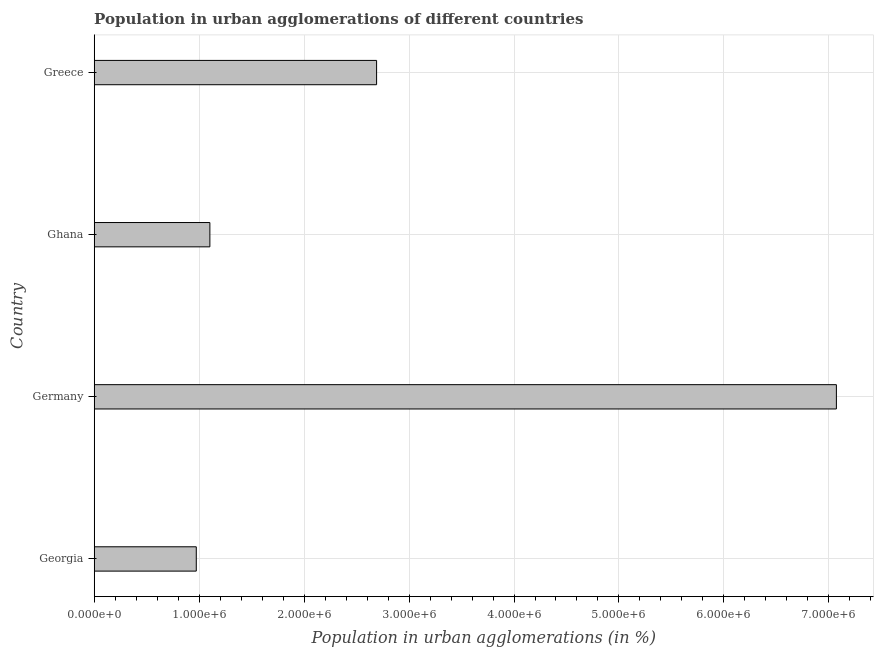What is the title of the graph?
Keep it short and to the point. Population in urban agglomerations of different countries. What is the label or title of the X-axis?
Your answer should be very brief. Population in urban agglomerations (in %). What is the label or title of the Y-axis?
Keep it short and to the point. Country. What is the population in urban agglomerations in Georgia?
Ensure brevity in your answer.  9.73e+05. Across all countries, what is the maximum population in urban agglomerations?
Your response must be concise. 7.07e+06. Across all countries, what is the minimum population in urban agglomerations?
Your response must be concise. 9.73e+05. In which country was the population in urban agglomerations minimum?
Offer a terse response. Georgia. What is the sum of the population in urban agglomerations?
Offer a terse response. 1.18e+07. What is the difference between the population in urban agglomerations in Georgia and Ghana?
Ensure brevity in your answer.  -1.29e+05. What is the average population in urban agglomerations per country?
Your answer should be compact. 2.96e+06. What is the median population in urban agglomerations?
Make the answer very short. 1.90e+06. What is the ratio of the population in urban agglomerations in Georgia to that in Greece?
Give a very brief answer. 0.36. Is the difference between the population in urban agglomerations in Georgia and Germany greater than the difference between any two countries?
Provide a succinct answer. Yes. What is the difference between the highest and the second highest population in urban agglomerations?
Offer a terse response. 4.38e+06. What is the difference between the highest and the lowest population in urban agglomerations?
Ensure brevity in your answer.  6.10e+06. How many bars are there?
Your answer should be compact. 4. Are all the bars in the graph horizontal?
Your answer should be compact. Yes. How many countries are there in the graph?
Give a very brief answer. 4. Are the values on the major ticks of X-axis written in scientific E-notation?
Ensure brevity in your answer.  Yes. What is the Population in urban agglomerations (in %) of Georgia?
Keep it short and to the point. 9.73e+05. What is the Population in urban agglomerations (in %) in Germany?
Ensure brevity in your answer.  7.07e+06. What is the Population in urban agglomerations (in %) of Ghana?
Your answer should be compact. 1.10e+06. What is the Population in urban agglomerations (in %) in Greece?
Provide a short and direct response. 2.69e+06. What is the difference between the Population in urban agglomerations (in %) in Georgia and Germany?
Provide a short and direct response. -6.10e+06. What is the difference between the Population in urban agglomerations (in %) in Georgia and Ghana?
Provide a succinct answer. -1.29e+05. What is the difference between the Population in urban agglomerations (in %) in Georgia and Greece?
Offer a very short reply. -1.72e+06. What is the difference between the Population in urban agglomerations (in %) in Germany and Ghana?
Ensure brevity in your answer.  5.97e+06. What is the difference between the Population in urban agglomerations (in %) in Germany and Greece?
Ensure brevity in your answer.  4.38e+06. What is the difference between the Population in urban agglomerations (in %) in Ghana and Greece?
Your answer should be very brief. -1.59e+06. What is the ratio of the Population in urban agglomerations (in %) in Georgia to that in Germany?
Offer a terse response. 0.14. What is the ratio of the Population in urban agglomerations (in %) in Georgia to that in Ghana?
Make the answer very short. 0.88. What is the ratio of the Population in urban agglomerations (in %) in Georgia to that in Greece?
Your answer should be very brief. 0.36. What is the ratio of the Population in urban agglomerations (in %) in Germany to that in Ghana?
Offer a terse response. 6.42. What is the ratio of the Population in urban agglomerations (in %) in Germany to that in Greece?
Offer a terse response. 2.63. What is the ratio of the Population in urban agglomerations (in %) in Ghana to that in Greece?
Offer a very short reply. 0.41. 